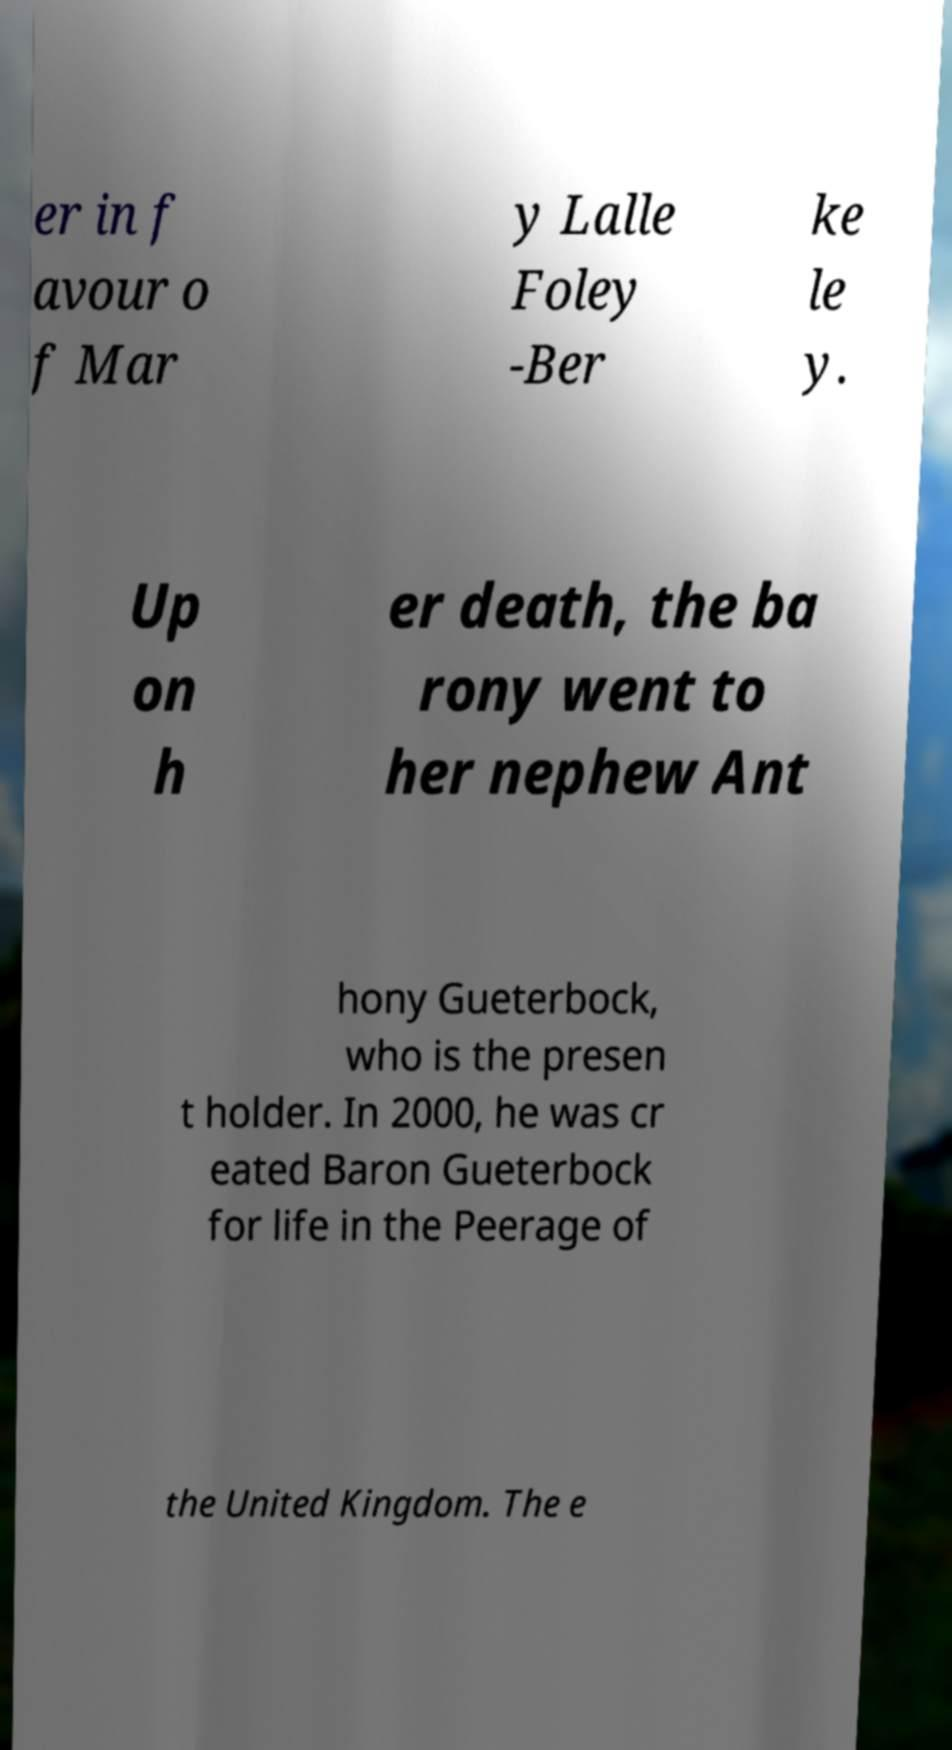Could you extract and type out the text from this image? er in f avour o f Mar y Lalle Foley -Ber ke le y. Up on h er death, the ba rony went to her nephew Ant hony Gueterbock, who is the presen t holder. In 2000, he was cr eated Baron Gueterbock for life in the Peerage of the United Kingdom. The e 